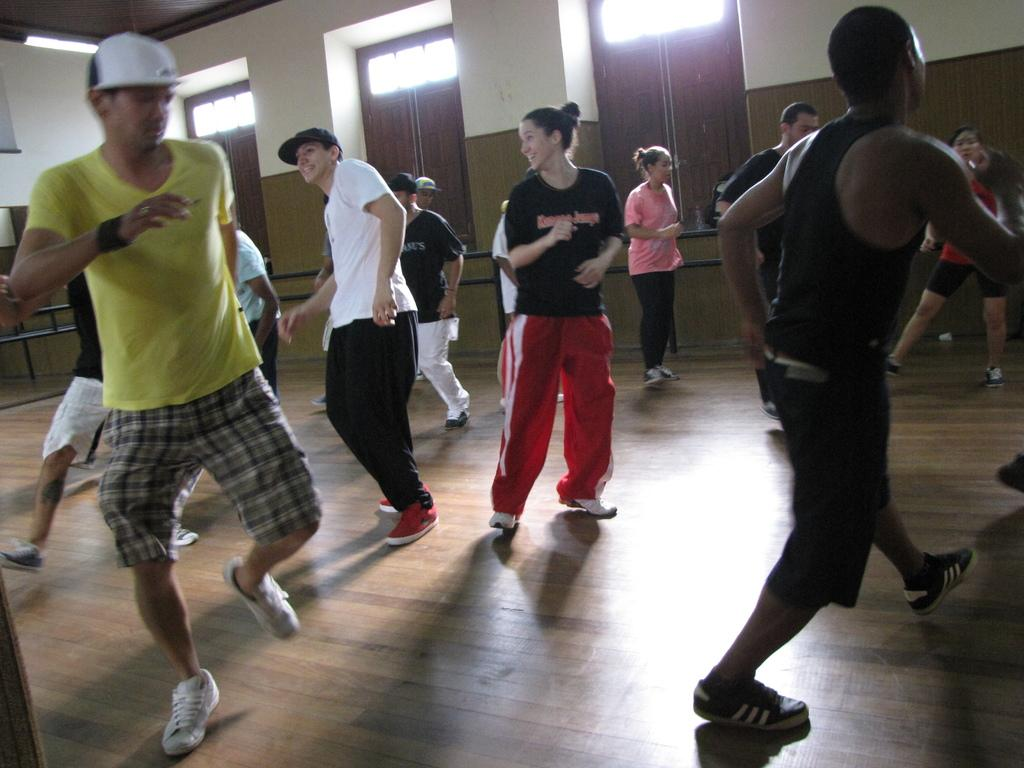What are the people in the image doing? There are many people dancing in the image. Can you describe the attire of some people in the image? Some people are wearing caps. What can be seen in the background of the image? There are windows and a wall visible in the background. What type of lighting is present in the image? There is a light on the ceiling. How many tickets are needed to enter the dance floor in the image? There is no mention of tickets or an entrance fee in the image; people are already dancing. What type of linen is draped over the boundary in the image? There is no linen or boundary present in the image. 